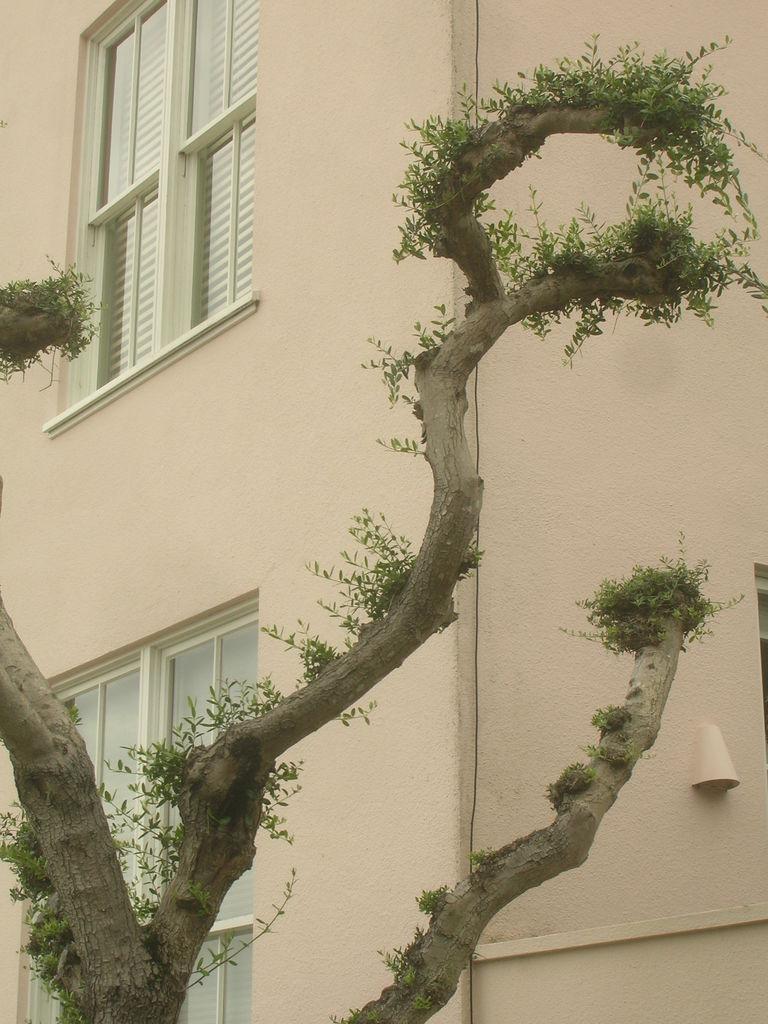Please provide a concise description of this image. In this picture we can see a building, windows. We can see a tree. 